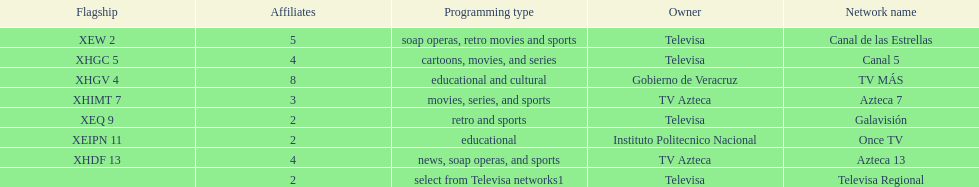Which owner has the most networks? Televisa. 